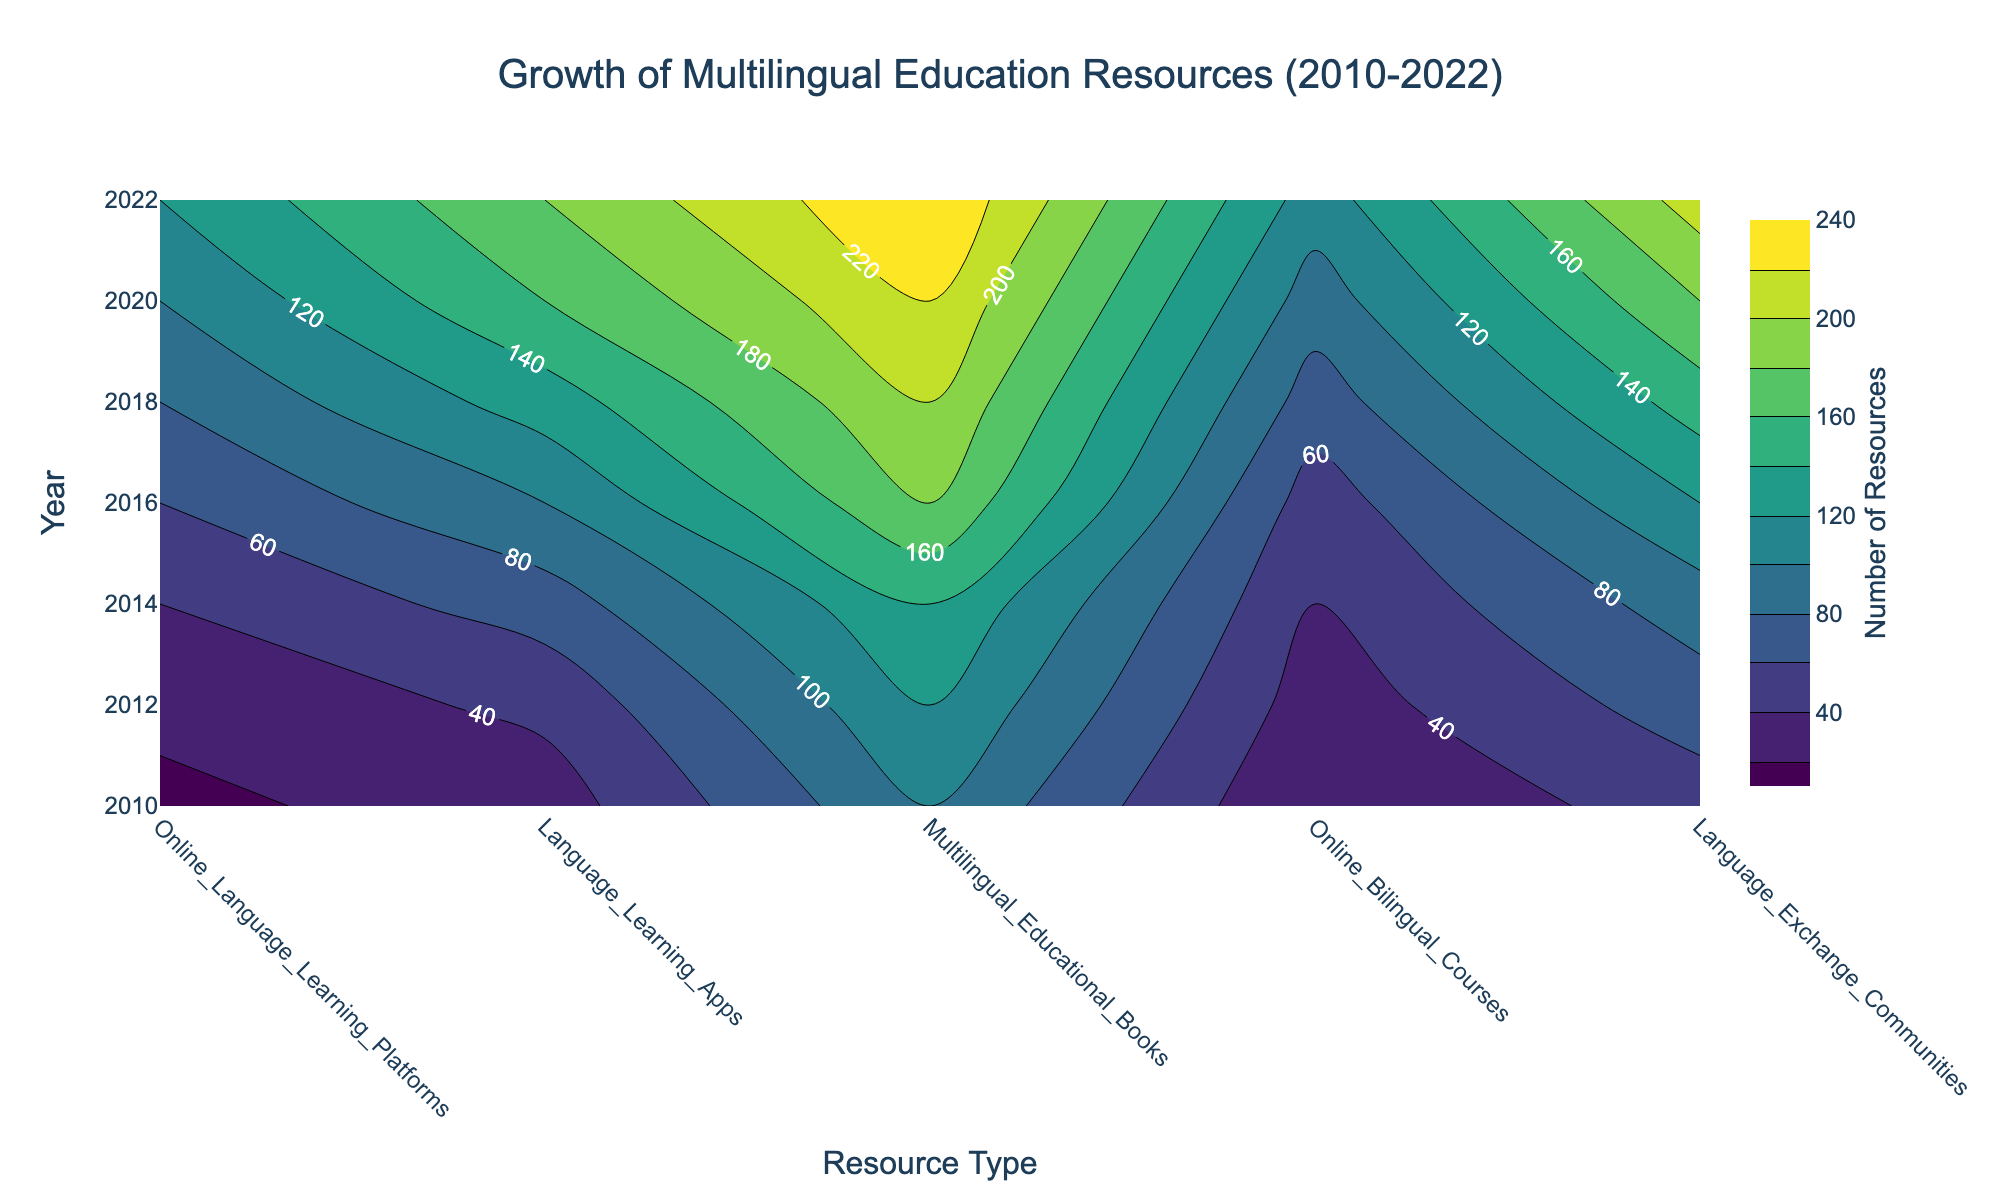What is the title of the contour plot? The title of the contour plot is displayed prominently at the top of the figure. By reading it, you will see the descriptive text that gives an overview of the visualized data.
Answer: Growth of Multilingual Education Resources (2010-2022) Which resource type had the fewest resources in 2010? By observing the contour plot in the year 2010 and comparing all resource types, you can identify the resource type with the lowest contour label value.
Answer: Language Exchange Communities How many resources were available for Online Language Learning Platforms in 2016? Locate the contour corresponding to the year 2016 and Online Language Learning Platforms, then read the label indicating the number of resources.
Answer: 120 Compare the number of Language Learning Apps available in 2014 and 2016. Which year had more, and by how much? Check the contour labels for Language Learning Apps in both 2014 and 2016, then subtract the value for 2014 from the value for 2016 to find the difference.
Answer: 2016 had 30 more resources What trend can you observe for Multilingual Educational Books from 2010 to 2022? Follow the contour lines for Multilingual Educational Books across the years from 2010 to 2022 and see how the values change over time, indicating the trend.
Answer: Increasing trend Which year shows the steepest increase in the number of Online Bilingual Courses from the previous year? Compare the contour labels for Online Bilingual Courses across consecutive years and identify the year with the largest increase in values.
Answer: 2018 Is the number of Language Exchange Communities higher in 2020 or 2022? Look at the contour labels for Language Exchange Communities in both 2020 and 2022, and compare the values directly.
Answer: 2022 What is the average number of Online Language Learning Platforms available across all years? Sum the number of Online Language Learning Platforms for each year (2010, 2012, 2014, 2016, 2018, 2020, 2022) and divide by the number of years (7).
Answer: 124.3 What does the color scale in the contour plot represent? The color scale next to the contour plot indicates the range of colors used to represent varying numbers of resources, with lighter colors typically showing higher values and darker colors showing lower values.
Answer: Number of Resources 